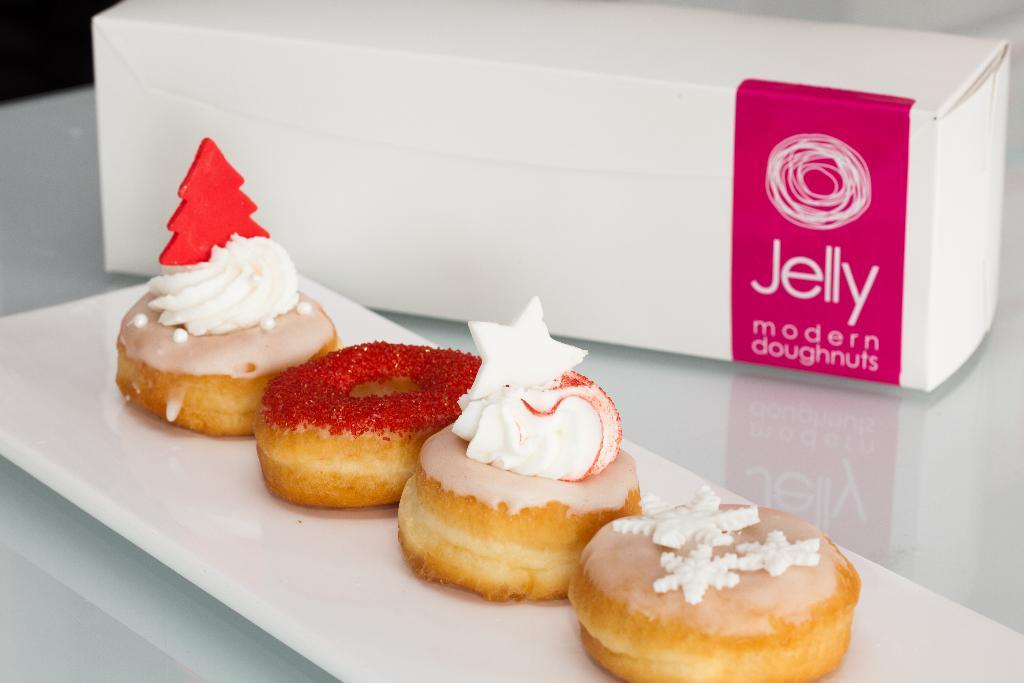How many doughnuts are visible in the image? There are four doughnuts in the image. Where are the doughnuts placed? The doughnuts are on a white tray. What else can be seen in the image besides the doughnuts? There is a box in the image. On what surface are the tray and box placed? The tray and box are placed on a platform. Can you see a tree in the image? No, there is no tree present in the image. 